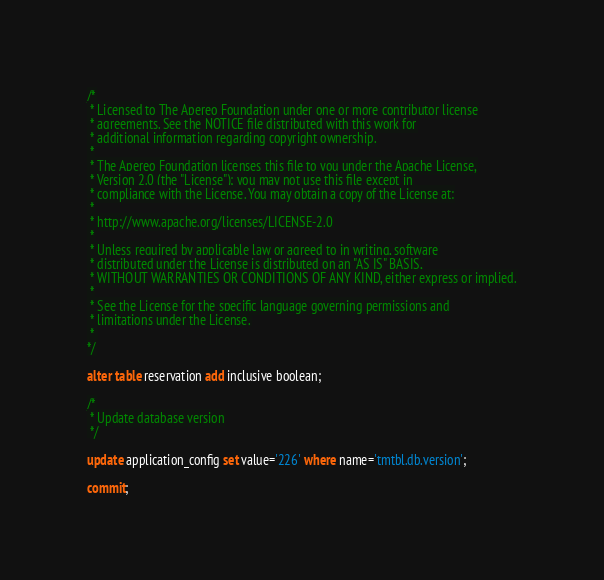Convert code to text. <code><loc_0><loc_0><loc_500><loc_500><_SQL_>/*
 * Licensed to The Apereo Foundation under one or more contributor license
 * agreements. See the NOTICE file distributed with this work for
 * additional information regarding copyright ownership.
 *
 * The Apereo Foundation licenses this file to you under the Apache License,
 * Version 2.0 (the "License"); you may not use this file except in
 * compliance with the License. You may obtain a copy of the License at:
 *
 * http://www.apache.org/licenses/LICENSE-2.0
 *
 * Unless required by applicable law or agreed to in writing, software
 * distributed under the License is distributed on an "AS IS" BASIS,
 * WITHOUT WARRANTIES OR CONDITIONS OF ANY KIND, either express or implied.
 *
 * See the License for the specific language governing permissions and
 * limitations under the License.
 * 
*/

alter table reservation add inclusive boolean;

/*
 * Update database version
 */

update application_config set value='226' where name='tmtbl.db.version';

commit;
</code> 